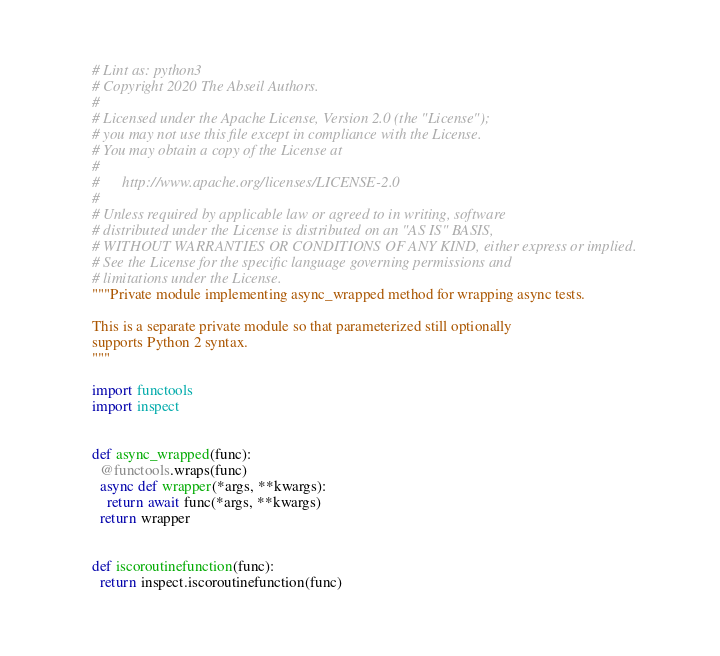<code> <loc_0><loc_0><loc_500><loc_500><_Python_># Lint as: python3
# Copyright 2020 The Abseil Authors.
#
# Licensed under the Apache License, Version 2.0 (the "License");
# you may not use this file except in compliance with the License.
# You may obtain a copy of the License at
#
#      http://www.apache.org/licenses/LICENSE-2.0
#
# Unless required by applicable law or agreed to in writing, software
# distributed under the License is distributed on an "AS IS" BASIS,
# WITHOUT WARRANTIES OR CONDITIONS OF ANY KIND, either express or implied.
# See the License for the specific language governing permissions and
# limitations under the License.
"""Private module implementing async_wrapped method for wrapping async tests.

This is a separate private module so that parameterized still optionally
supports Python 2 syntax.
"""

import functools
import inspect


def async_wrapped(func):
  @functools.wraps(func)
  async def wrapper(*args, **kwargs):
    return await func(*args, **kwargs)
  return wrapper


def iscoroutinefunction(func):
  return inspect.iscoroutinefunction(func)
</code> 